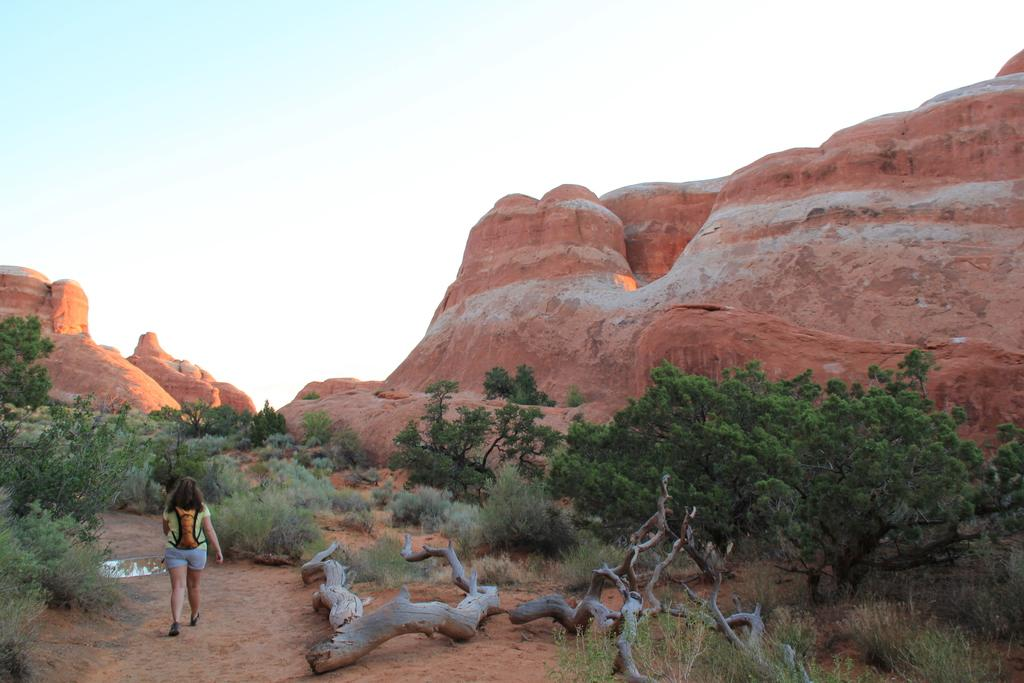Who is present in the image? There is a woman in the image. What is the woman doing in the image? The woman is walking in the left corner of the image. What can be seen in the background of the image? There are trees and mountains in the background of the image. What type of gold record can be seen in the image? There is no gold record present in the image; it features a woman walking in the left corner with trees and mountains in the background. 